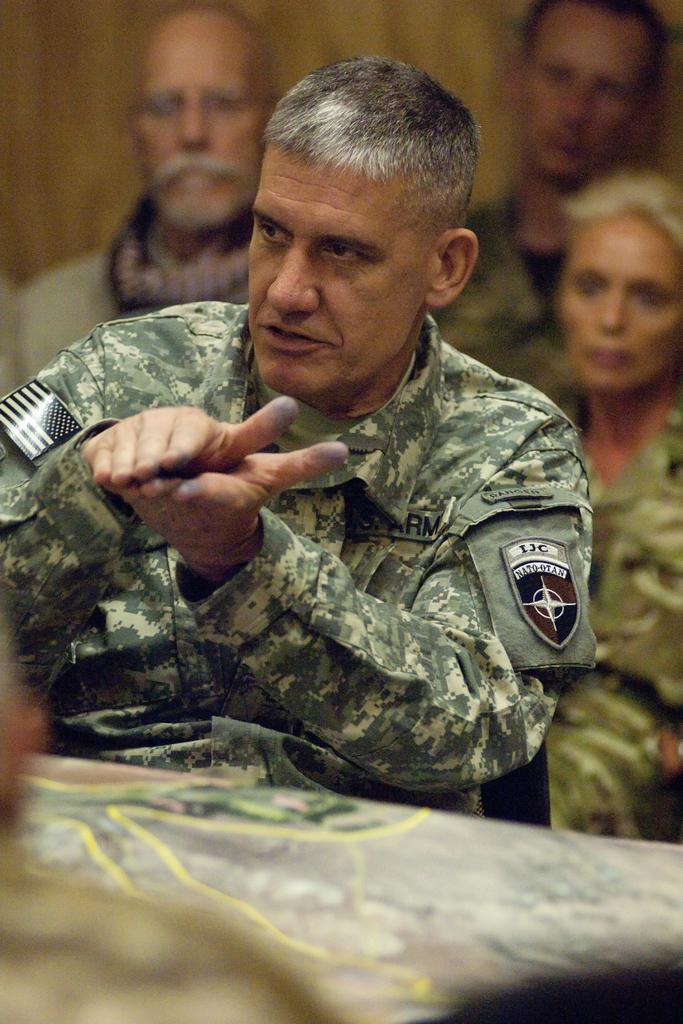How would you summarize this image in a sentence or two? In this image, we can see a person is sitting and talking. He is seeing towards left side and doing hands movement. Background there is a blur view. Here we can see few people. At the bottom, there is a map. 